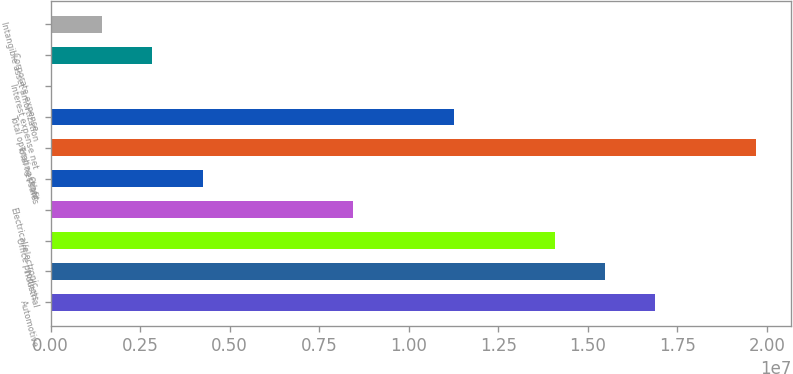Convert chart. <chart><loc_0><loc_0><loc_500><loc_500><bar_chart><fcel>Automotive<fcel>Industrial<fcel>Office products<fcel>Electrical/electronic<fcel>Other<fcel>Total net sales<fcel>Total operating profit<fcel>Interest expense net<fcel>Corporate expense<fcel>Intangible asset amortization<nl><fcel>1.68885e+07<fcel>1.54832e+07<fcel>1.40778e+07<fcel>8.45644e+06<fcel>4.24038e+06<fcel>1.96992e+07<fcel>1.12671e+07<fcel>24330<fcel>2.83503e+06<fcel>1.42968e+06<nl></chart> 